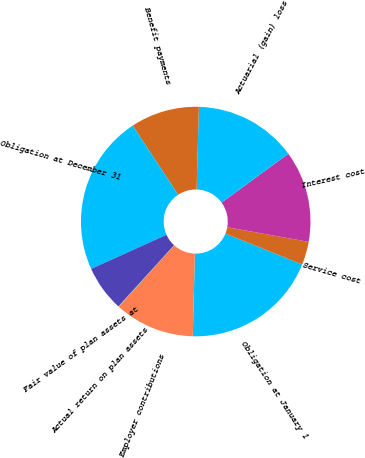Convert chart to OTSL. <chart><loc_0><loc_0><loc_500><loc_500><pie_chart><fcel>Obligation at January 1<fcel>Service cost<fcel>Interest cost<fcel>Actuarial (gain) loss<fcel>Benefit payments<fcel>Obligation at December 31<fcel>Fair value of plan assets at<fcel>Actual return on plan assets<fcel>Employer contributions<nl><fcel>19.31%<fcel>3.27%<fcel>12.89%<fcel>14.5%<fcel>9.69%<fcel>22.52%<fcel>6.48%<fcel>0.06%<fcel>11.29%<nl></chart> 